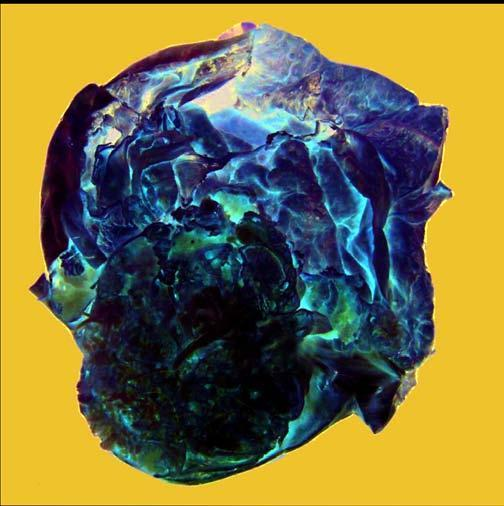what shows a very large multilocular cyst without papillae?
Answer the question using a single word or phrase. Cut surface 